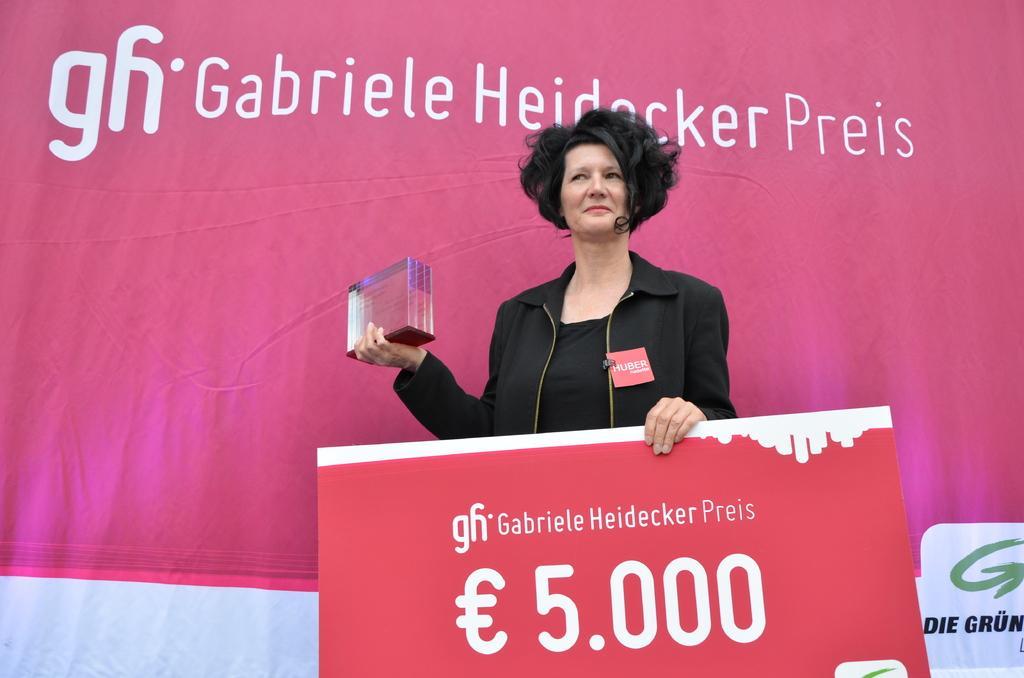How would you summarize this image in a sentence or two? This image is taken outdoors. In the background there is a banner with a text on it. In the middle of the image a woman in standing and she is holding an object and a board with a text on it in her hands. She is with a smiling face. 